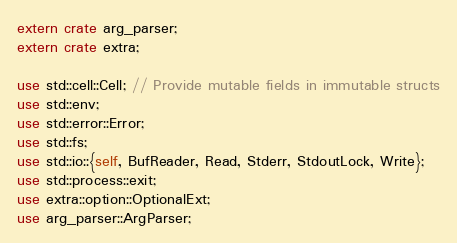<code> <loc_0><loc_0><loc_500><loc_500><_Rust_>extern crate arg_parser;
extern crate extra;

use std::cell::Cell; // Provide mutable fields in immutable structs
use std::env;
use std::error::Error;
use std::fs;
use std::io::{self, BufReader, Read, Stderr, StdoutLock, Write};
use std::process::exit;
use extra::option::OptionalExt;
use arg_parser::ArgParser;
</code> 